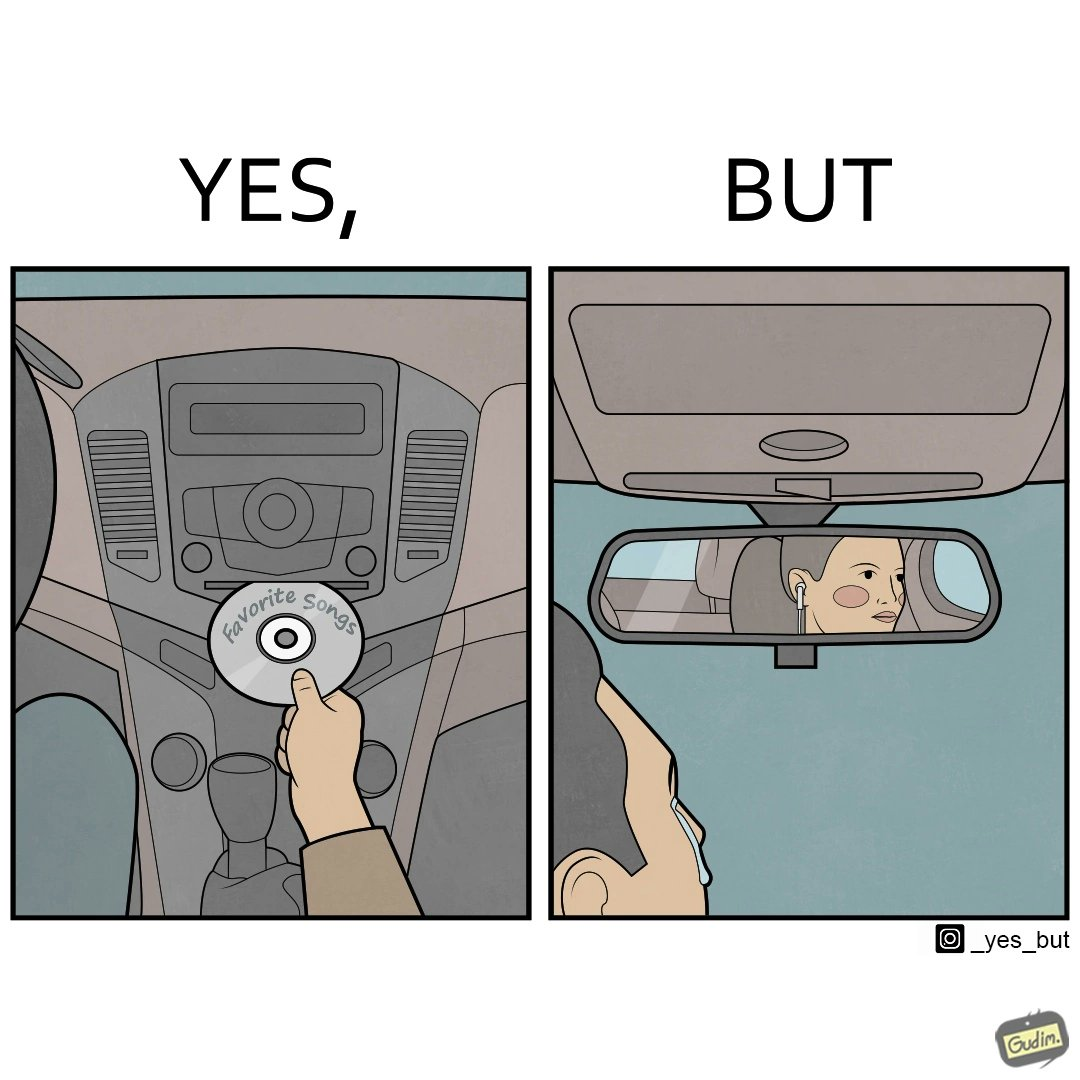Explain why this image is satirical. The image is funny, as the driver of the car inserts a CD named "Favorite Songs" into the CD player for the passenger, but the driver is sad on seeing the passenger in the back seat listening to something else on earphones instead. 